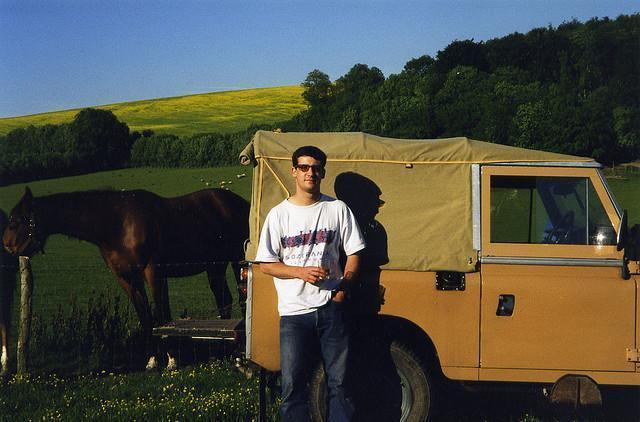How many surfboards are there?
Give a very brief answer. 0. 